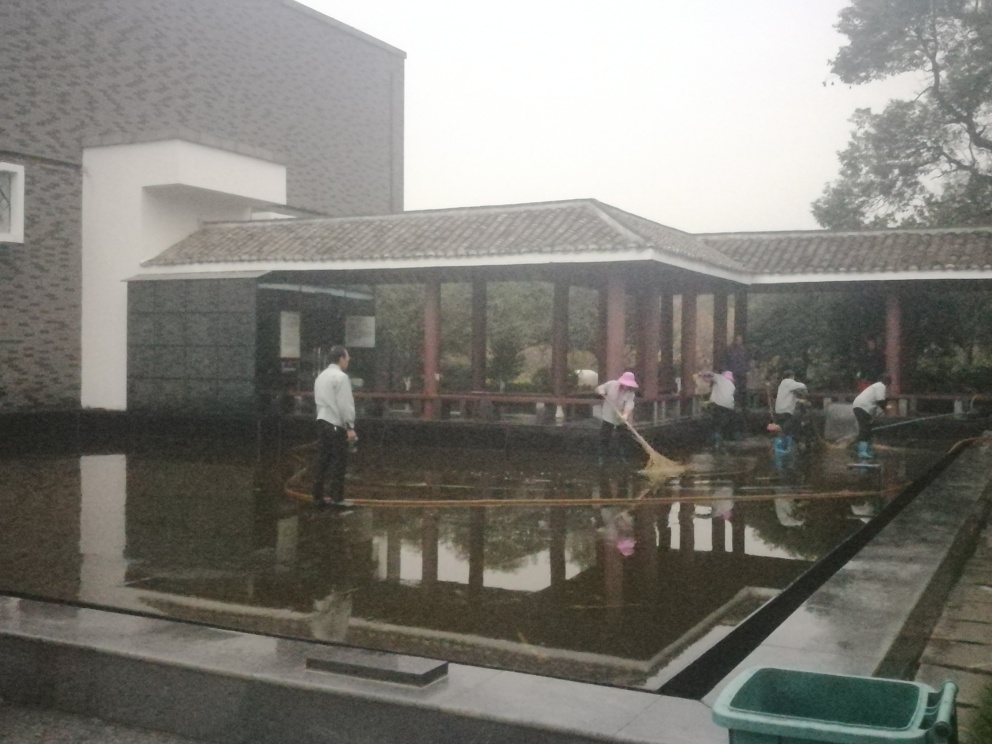How is the background of the image?
A. Focused
B. Blurry.
C. Clear
D. Detailed The background of the image appears to be Blurry, with elements like trees and building structures lacking sharpness and detail. 